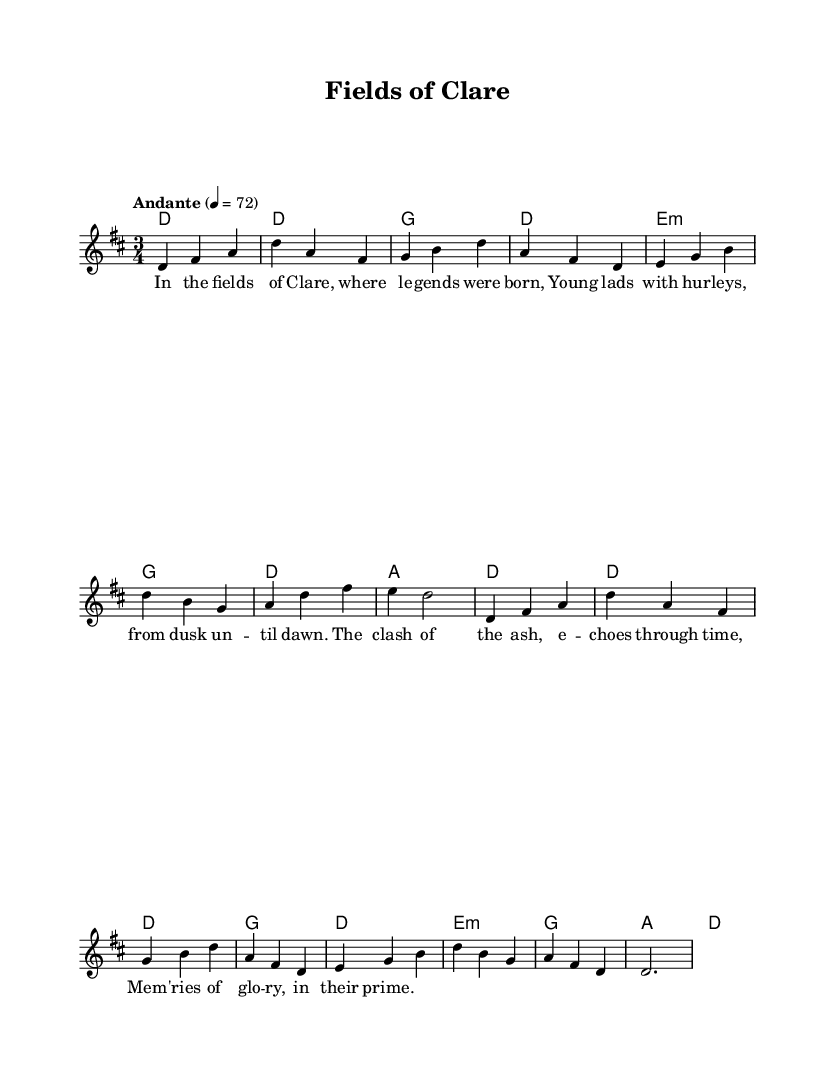What is the key signature of this music? The key signature shows that there are two sharps, which indicates that the key is D major.
Answer: D major What is the time signature of this music? The time signature is represented by the numbers 3 and 4, meaning there are three beats in a measure and the quarter note gets one beat.
Answer: 3/4 What is the tempo marking of this music? The tempo marking indicates "Andante" with a metronome marking of 72, suggesting a moderately slow pace.
Answer: Andante 72 How many measures are present in the melody part? By counting the measure lines in the melody, we see there are 12 measures in total.
Answer: 12 What are the first four notes of the melody? The first four notes of the melody in sequence are D, F sharp, A, D.
Answer: D, F sharp, A, D Which chord follows the first measure of the melody? The first measure is accompanied by a dotted D chord, indicating a sustained D major chord.
Answer: D What is the theme of the lyrics in the song? The lyrics emphasize memories of glory and the heroic times spent playing hurling in Clare's fields.
Answer: Nostalgic ballads about hurling 